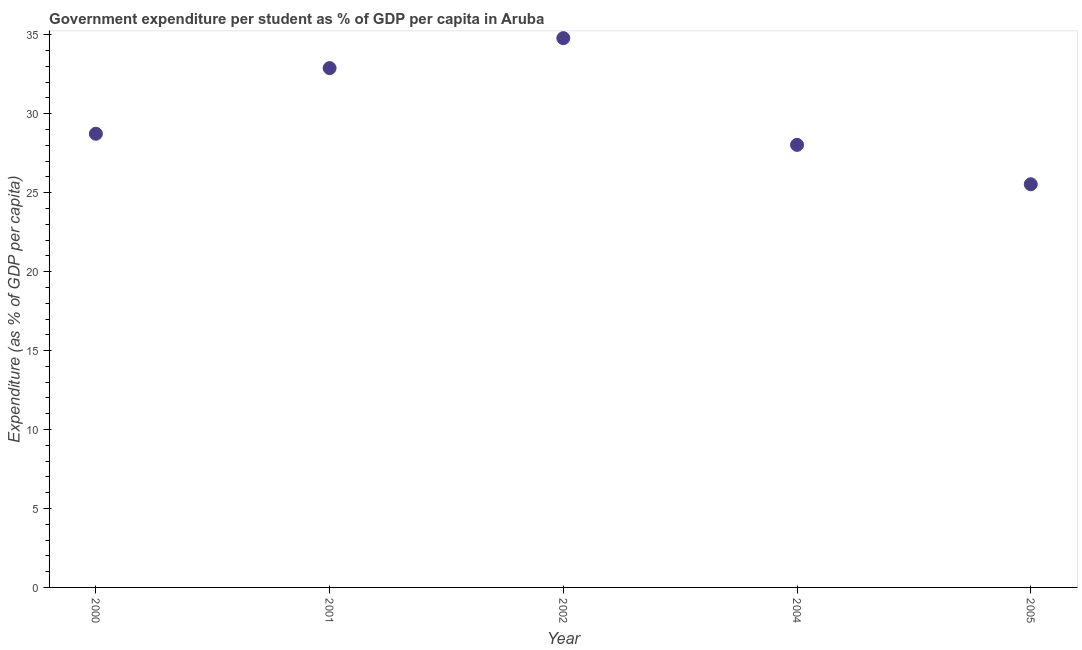What is the government expenditure per student in 2005?
Make the answer very short. 25.53. Across all years, what is the maximum government expenditure per student?
Keep it short and to the point. 34.79. Across all years, what is the minimum government expenditure per student?
Provide a short and direct response. 25.53. In which year was the government expenditure per student maximum?
Your response must be concise. 2002. In which year was the government expenditure per student minimum?
Offer a very short reply. 2005. What is the sum of the government expenditure per student?
Your answer should be very brief. 149.98. What is the difference between the government expenditure per student in 2001 and 2005?
Provide a succinct answer. 7.36. What is the average government expenditure per student per year?
Give a very brief answer. 30. What is the median government expenditure per student?
Make the answer very short. 28.73. What is the ratio of the government expenditure per student in 2002 to that in 2004?
Ensure brevity in your answer.  1.24. Is the government expenditure per student in 2000 less than that in 2005?
Your answer should be compact. No. What is the difference between the highest and the second highest government expenditure per student?
Offer a terse response. 1.9. Is the sum of the government expenditure per student in 2001 and 2002 greater than the maximum government expenditure per student across all years?
Make the answer very short. Yes. What is the difference between the highest and the lowest government expenditure per student?
Provide a succinct answer. 9.26. How many dotlines are there?
Keep it short and to the point. 1. What is the difference between two consecutive major ticks on the Y-axis?
Your answer should be very brief. 5. What is the title of the graph?
Offer a terse response. Government expenditure per student as % of GDP per capita in Aruba. What is the label or title of the Y-axis?
Provide a succinct answer. Expenditure (as % of GDP per capita). What is the Expenditure (as % of GDP per capita) in 2000?
Provide a succinct answer. 28.73. What is the Expenditure (as % of GDP per capita) in 2001?
Provide a succinct answer. 32.89. What is the Expenditure (as % of GDP per capita) in 2002?
Ensure brevity in your answer.  34.79. What is the Expenditure (as % of GDP per capita) in 2004?
Your response must be concise. 28.03. What is the Expenditure (as % of GDP per capita) in 2005?
Make the answer very short. 25.53. What is the difference between the Expenditure (as % of GDP per capita) in 2000 and 2001?
Make the answer very short. -4.16. What is the difference between the Expenditure (as % of GDP per capita) in 2000 and 2002?
Give a very brief answer. -6.06. What is the difference between the Expenditure (as % of GDP per capita) in 2000 and 2004?
Ensure brevity in your answer.  0.7. What is the difference between the Expenditure (as % of GDP per capita) in 2000 and 2005?
Make the answer very short. 3.2. What is the difference between the Expenditure (as % of GDP per capita) in 2001 and 2002?
Your answer should be compact. -1.9. What is the difference between the Expenditure (as % of GDP per capita) in 2001 and 2004?
Provide a succinct answer. 4.86. What is the difference between the Expenditure (as % of GDP per capita) in 2001 and 2005?
Provide a succinct answer. 7.36. What is the difference between the Expenditure (as % of GDP per capita) in 2002 and 2004?
Your answer should be very brief. 6.76. What is the difference between the Expenditure (as % of GDP per capita) in 2002 and 2005?
Provide a short and direct response. 9.26. What is the difference between the Expenditure (as % of GDP per capita) in 2004 and 2005?
Your response must be concise. 2.49. What is the ratio of the Expenditure (as % of GDP per capita) in 2000 to that in 2001?
Your answer should be compact. 0.87. What is the ratio of the Expenditure (as % of GDP per capita) in 2000 to that in 2002?
Provide a succinct answer. 0.83. What is the ratio of the Expenditure (as % of GDP per capita) in 2000 to that in 2004?
Make the answer very short. 1.02. What is the ratio of the Expenditure (as % of GDP per capita) in 2001 to that in 2002?
Give a very brief answer. 0.94. What is the ratio of the Expenditure (as % of GDP per capita) in 2001 to that in 2004?
Offer a terse response. 1.17. What is the ratio of the Expenditure (as % of GDP per capita) in 2001 to that in 2005?
Your answer should be very brief. 1.29. What is the ratio of the Expenditure (as % of GDP per capita) in 2002 to that in 2004?
Your answer should be compact. 1.24. What is the ratio of the Expenditure (as % of GDP per capita) in 2002 to that in 2005?
Keep it short and to the point. 1.36. What is the ratio of the Expenditure (as % of GDP per capita) in 2004 to that in 2005?
Make the answer very short. 1.1. 